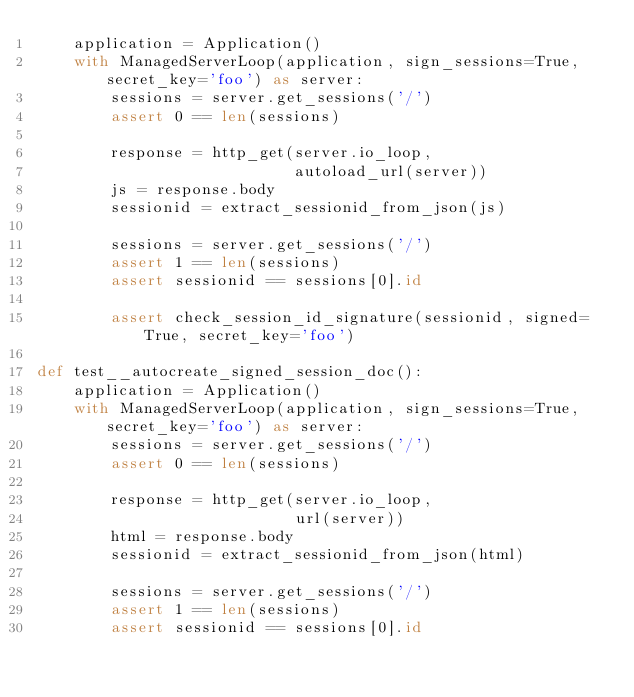<code> <loc_0><loc_0><loc_500><loc_500><_Python_>    application = Application()
    with ManagedServerLoop(application, sign_sessions=True, secret_key='foo') as server:
        sessions = server.get_sessions('/')
        assert 0 == len(sessions)

        response = http_get(server.io_loop,
                            autoload_url(server))
        js = response.body
        sessionid = extract_sessionid_from_json(js)

        sessions = server.get_sessions('/')
        assert 1 == len(sessions)
        assert sessionid == sessions[0].id

        assert check_session_id_signature(sessionid, signed=True, secret_key='foo')

def test__autocreate_signed_session_doc():
    application = Application()
    with ManagedServerLoop(application, sign_sessions=True, secret_key='foo') as server:
        sessions = server.get_sessions('/')
        assert 0 == len(sessions)

        response = http_get(server.io_loop,
                            url(server))
        html = response.body
        sessionid = extract_sessionid_from_json(html)

        sessions = server.get_sessions('/')
        assert 1 == len(sessions)
        assert sessionid == sessions[0].id
</code> 